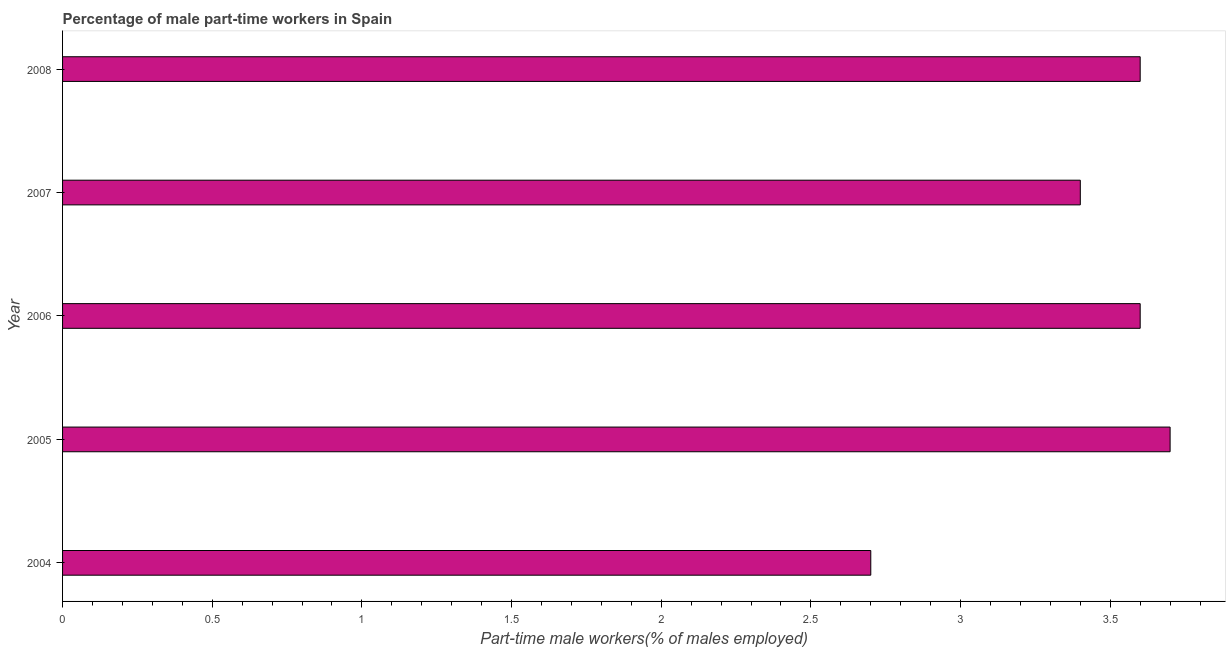What is the title of the graph?
Keep it short and to the point. Percentage of male part-time workers in Spain. What is the label or title of the X-axis?
Keep it short and to the point. Part-time male workers(% of males employed). What is the label or title of the Y-axis?
Provide a succinct answer. Year. What is the percentage of part-time male workers in 2006?
Offer a very short reply. 3.6. Across all years, what is the maximum percentage of part-time male workers?
Keep it short and to the point. 3.7. Across all years, what is the minimum percentage of part-time male workers?
Offer a very short reply. 2.7. In which year was the percentage of part-time male workers maximum?
Your response must be concise. 2005. What is the sum of the percentage of part-time male workers?
Make the answer very short. 17. What is the median percentage of part-time male workers?
Ensure brevity in your answer.  3.6. Do a majority of the years between 2008 and 2004 (inclusive) have percentage of part-time male workers greater than 1.7 %?
Offer a very short reply. Yes. What is the ratio of the percentage of part-time male workers in 2006 to that in 2007?
Make the answer very short. 1.06. Is the percentage of part-time male workers in 2004 less than that in 2007?
Make the answer very short. Yes. Is the difference between the percentage of part-time male workers in 2007 and 2008 greater than the difference between any two years?
Make the answer very short. No. Is the sum of the percentage of part-time male workers in 2004 and 2008 greater than the maximum percentage of part-time male workers across all years?
Provide a succinct answer. Yes. What is the difference between the highest and the lowest percentage of part-time male workers?
Ensure brevity in your answer.  1. In how many years, is the percentage of part-time male workers greater than the average percentage of part-time male workers taken over all years?
Offer a terse response. 4. How many bars are there?
Your answer should be compact. 5. What is the difference between two consecutive major ticks on the X-axis?
Your answer should be compact. 0.5. What is the Part-time male workers(% of males employed) in 2004?
Make the answer very short. 2.7. What is the Part-time male workers(% of males employed) in 2005?
Provide a short and direct response. 3.7. What is the Part-time male workers(% of males employed) in 2006?
Give a very brief answer. 3.6. What is the Part-time male workers(% of males employed) of 2007?
Your response must be concise. 3.4. What is the Part-time male workers(% of males employed) in 2008?
Keep it short and to the point. 3.6. What is the difference between the Part-time male workers(% of males employed) in 2004 and 2005?
Your answer should be very brief. -1. What is the difference between the Part-time male workers(% of males employed) in 2004 and 2007?
Offer a very short reply. -0.7. What is the difference between the Part-time male workers(% of males employed) in 2004 and 2008?
Keep it short and to the point. -0.9. What is the difference between the Part-time male workers(% of males employed) in 2005 and 2007?
Provide a succinct answer. 0.3. What is the difference between the Part-time male workers(% of males employed) in 2006 and 2008?
Provide a short and direct response. 0. What is the ratio of the Part-time male workers(% of males employed) in 2004 to that in 2005?
Ensure brevity in your answer.  0.73. What is the ratio of the Part-time male workers(% of males employed) in 2004 to that in 2007?
Give a very brief answer. 0.79. What is the ratio of the Part-time male workers(% of males employed) in 2005 to that in 2006?
Offer a terse response. 1.03. What is the ratio of the Part-time male workers(% of males employed) in 2005 to that in 2007?
Ensure brevity in your answer.  1.09. What is the ratio of the Part-time male workers(% of males employed) in 2005 to that in 2008?
Provide a short and direct response. 1.03. What is the ratio of the Part-time male workers(% of males employed) in 2006 to that in 2007?
Keep it short and to the point. 1.06. What is the ratio of the Part-time male workers(% of males employed) in 2006 to that in 2008?
Give a very brief answer. 1. What is the ratio of the Part-time male workers(% of males employed) in 2007 to that in 2008?
Provide a succinct answer. 0.94. 